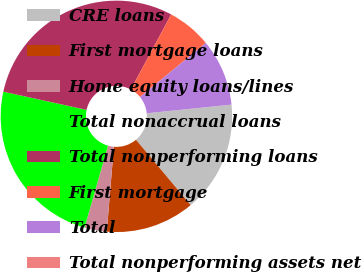<chart> <loc_0><loc_0><loc_500><loc_500><pie_chart><fcel>CRE loans<fcel>First mortgage loans<fcel>Home equity loans/lines<fcel>Total nonaccrual loans<fcel>Total nonperforming loans<fcel>First mortgage<fcel>Total<fcel>Total nonperforming assets net<nl><fcel>15.53%<fcel>12.42%<fcel>3.11%<fcel>23.99%<fcel>29.44%<fcel>6.21%<fcel>9.32%<fcel>0.0%<nl></chart> 